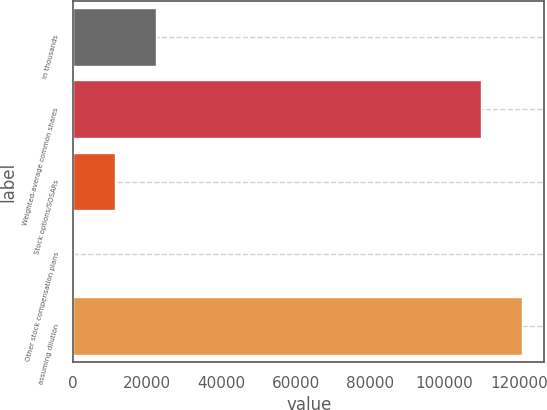<chart> <loc_0><loc_0><loc_500><loc_500><bar_chart><fcel>in thousands<fcel>Weighted-average common shares<fcel>Stock options/SOSARs<fcel>Other stock compensation plans<fcel>assuming dilution<nl><fcel>22410.8<fcel>109774<fcel>11342.9<fcel>275<fcel>120842<nl></chart> 